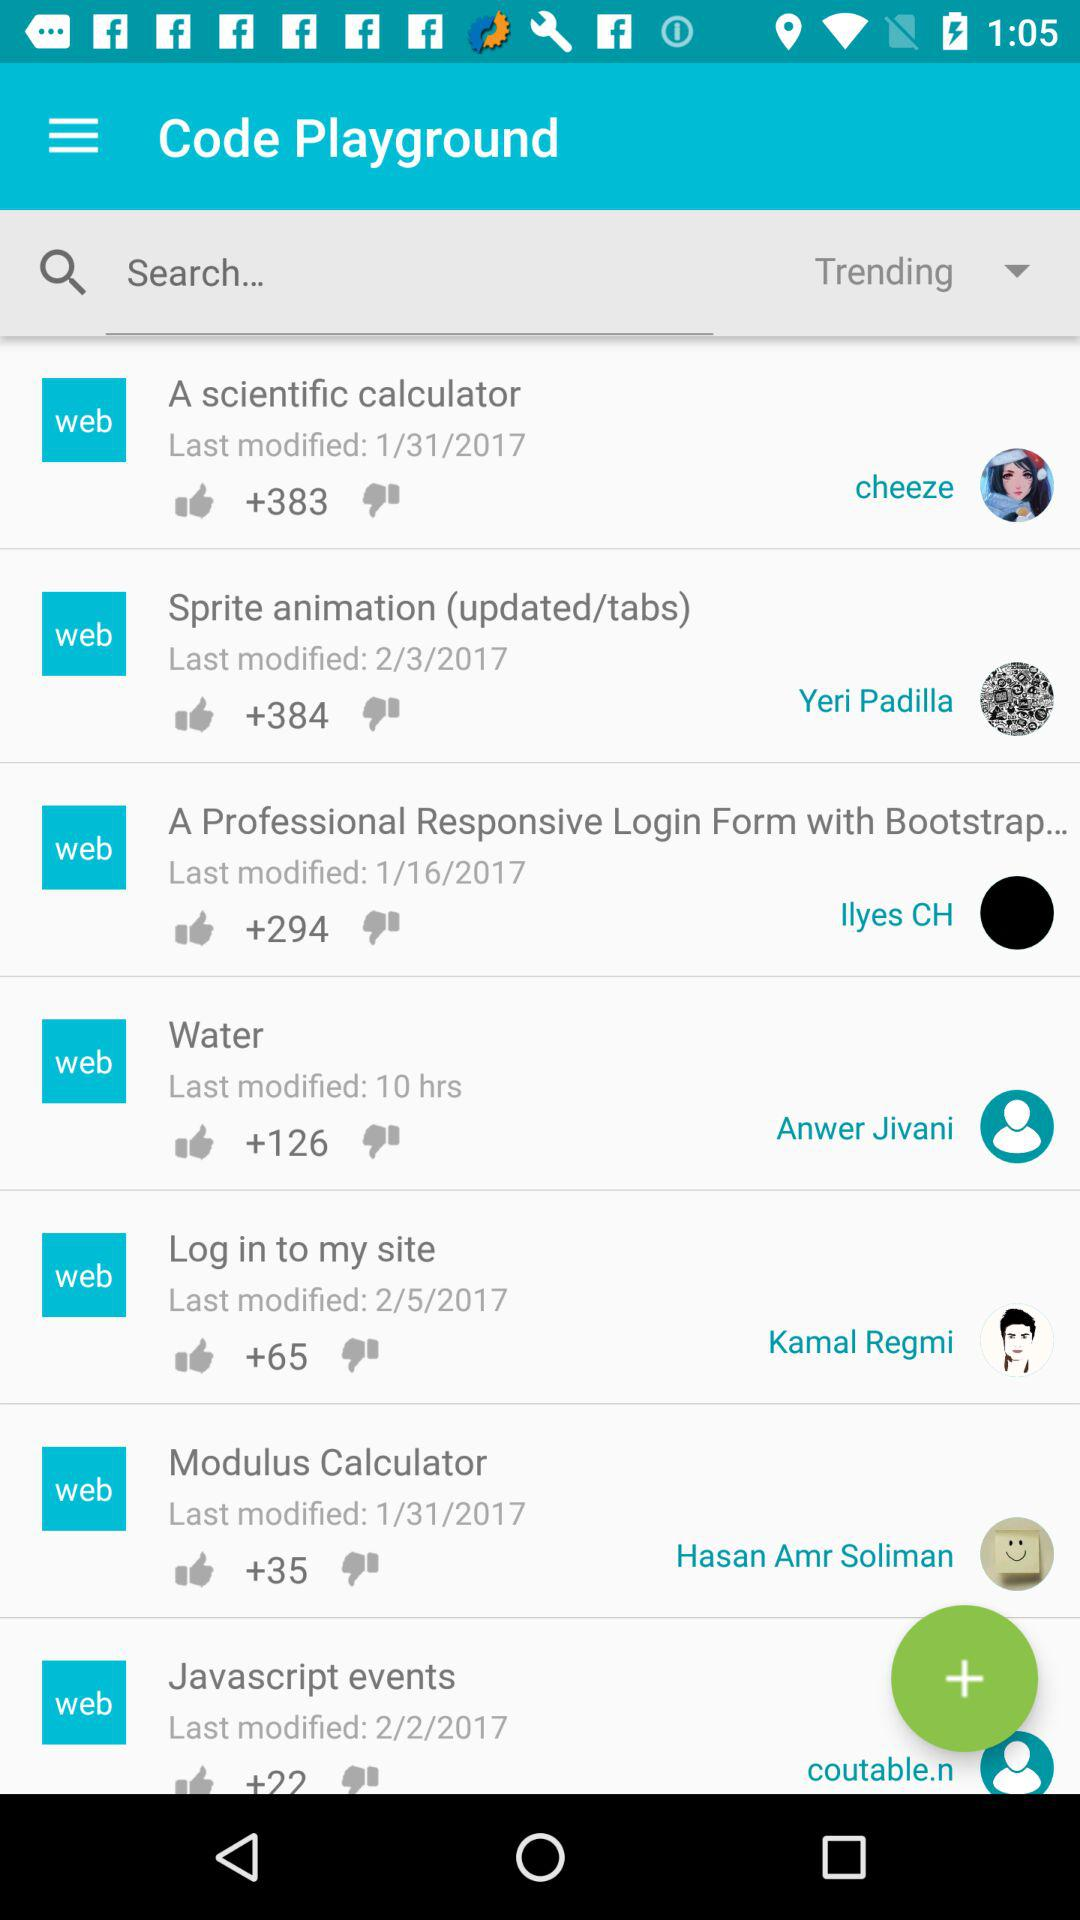How many likes are there for "Water"? There are +126 likes for "Water". 